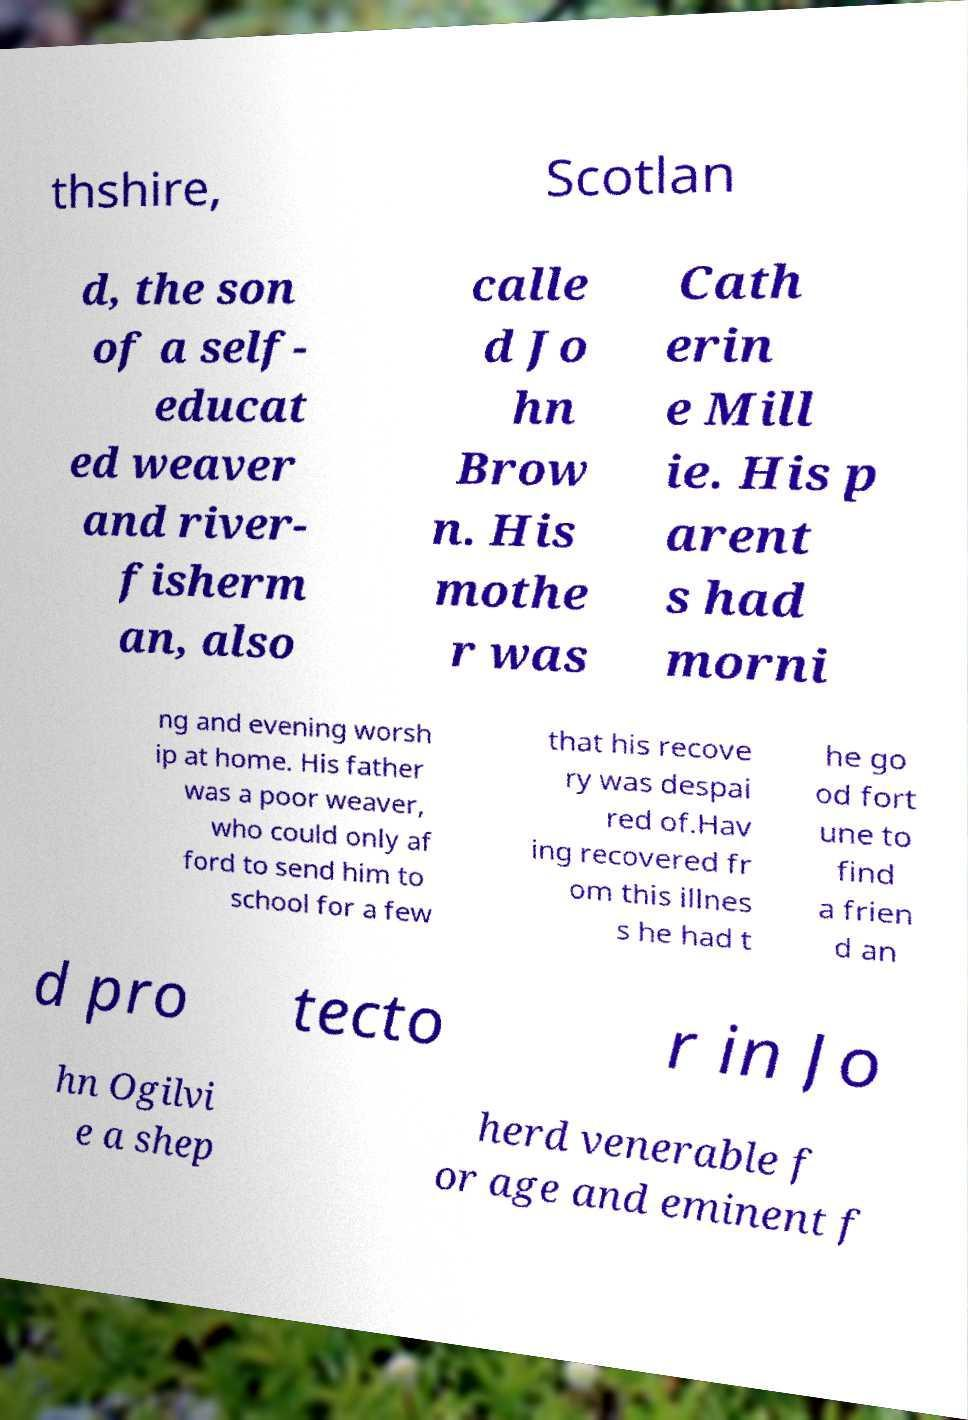Could you assist in decoding the text presented in this image and type it out clearly? thshire, Scotlan d, the son of a self- educat ed weaver and river- fisherm an, also calle d Jo hn Brow n. His mothe r was Cath erin e Mill ie. His p arent s had morni ng and evening worsh ip at home. His father was a poor weaver, who could only af ford to send him to school for a few that his recove ry was despai red of.Hav ing recovered fr om this illnes s he had t he go od fort une to find a frien d an d pro tecto r in Jo hn Ogilvi e a shep herd venerable f or age and eminent f 